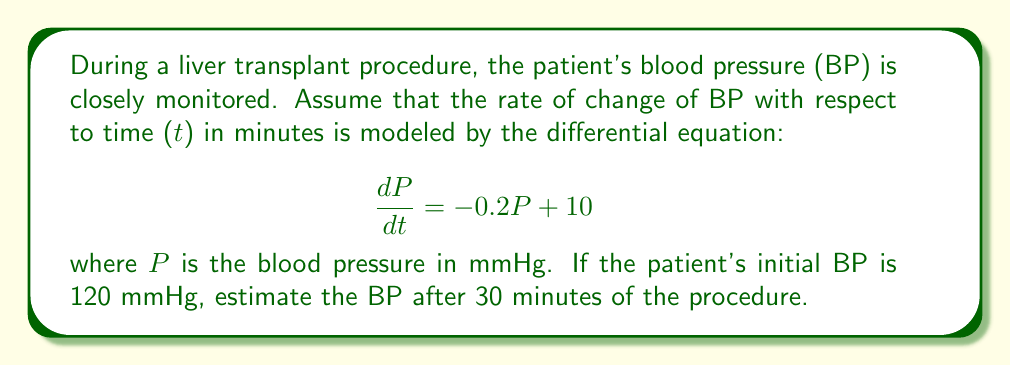Show me your answer to this math problem. To solve this problem, we need to use the method for solving first-order linear differential equations.

1) The general form of a first-order linear differential equation is:

   $$\frac{dy}{dx} + P(x)y = Q(x)$$

2) In our case, we have:

   $$\frac{dP}{dt} = -0.2P + 10$$

   This can be rewritten as:

   $$\frac{dP}{dt} + 0.2P = 10$$

3) The integrating factor is $e^{\int P(x)dx}$. Here, $P(x) = 0.2$, so:

   Integrating factor = $e^{\int 0.2 dt} = e^{0.2t}$

4) Multiply both sides of the equation by the integrating factor:

   $$e^{0.2t}\frac{dP}{dt} + 0.2e^{0.2t}P = 10e^{0.2t}$$

5) The left side is now the derivative of $e^{0.2t}P$:

   $$\frac{d}{dt}(e^{0.2t}P) = 10e^{0.2t}$$

6) Integrate both sides:

   $$e^{0.2t}P = 50e^{0.2t} + C$$

7) Solve for P:

   $$P = 50 + Ce^{-0.2t}$$

8) Use the initial condition P(0) = 120 to find C:

   $$120 = 50 + C$$
   $$C = 70$$

9) Therefore, the general solution is:

   $$P = 50 + 70e^{-0.2t}$$

10) To find P after 30 minutes, substitute t = 30:

    $$P(30) = 50 + 70e^{-0.2(30)} \approx 81.37$$
Answer: The estimated blood pressure after 30 minutes of the liver transplant procedure is approximately 81.37 mmHg. 